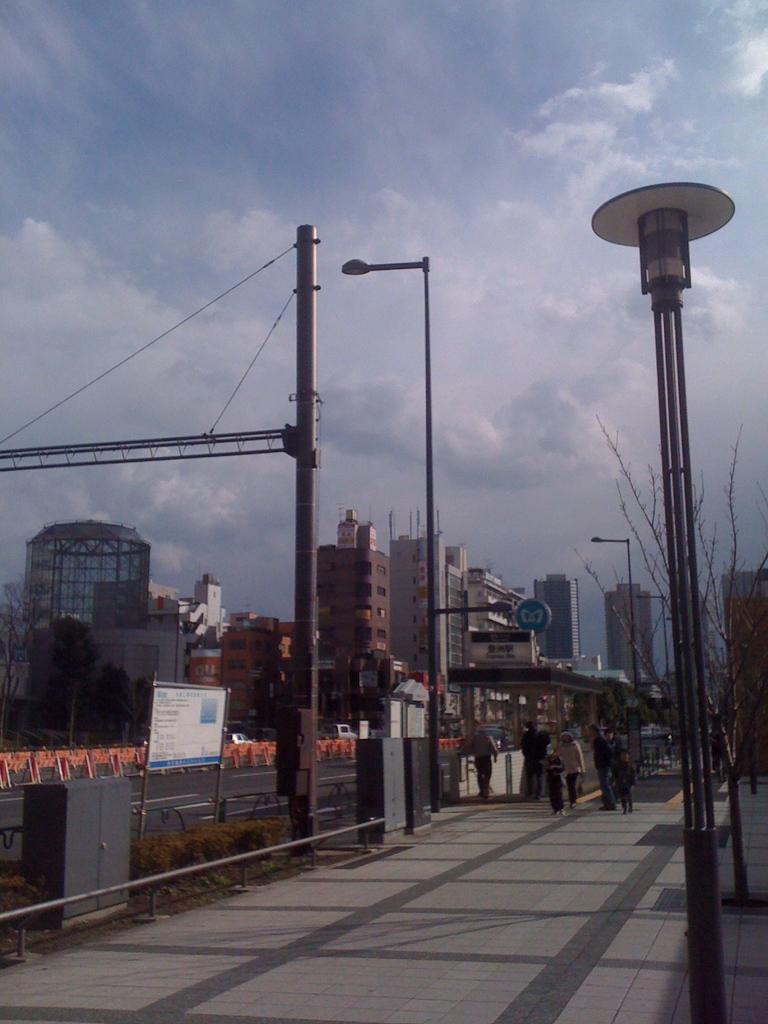Can you describe this image briefly? In this picture we can see some people are walking and some people are standing on the path and behind the people there are poles with lights and on the roads there are barriers. Behind the poles there are trees, buildings and a cloudy sky. 